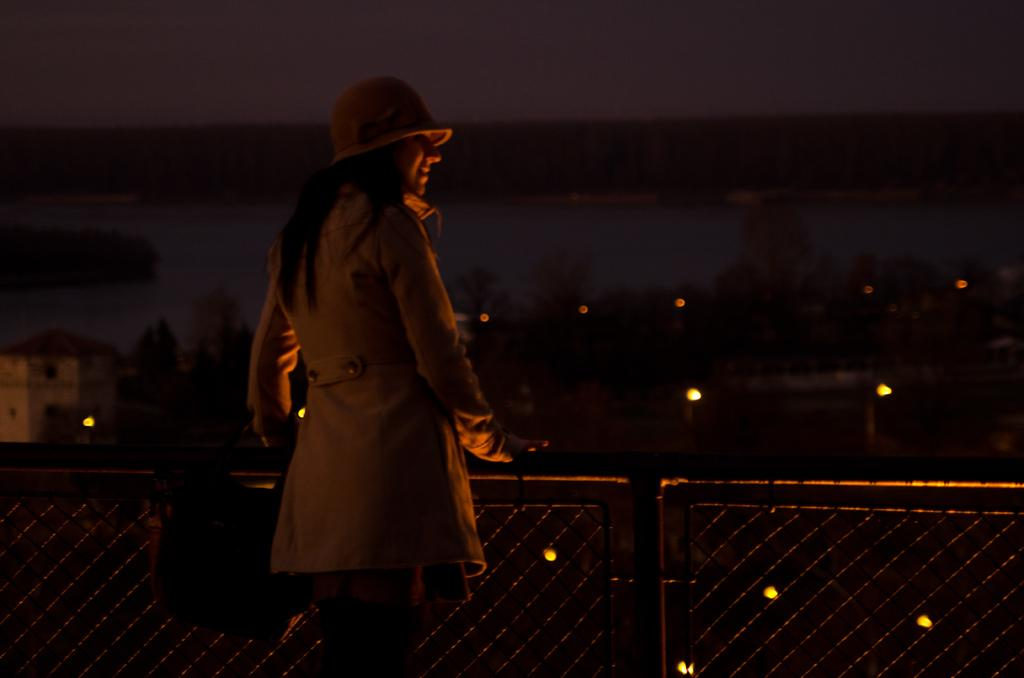Who is present in the image? There is a woman in the image. What is the woman wearing on her head? The woman is wearing a hat. What is the woman's posture in the image? The woman is standing. What type of structures can be seen in the image? There are buildings in the image. What type of vegetation is present in the image? There are trees in the image. What type of illumination is present in the image? There are lights in the image. What type of natural element is visible in the image? There is water visible in the image. What type of barrier is present in the image? There is a fence in the image. What can be seen in the background of the image? The sky is visible in the background of the image. What type of fowl can be seen flying over the fence in the image? There is no fowl visible in the image; it only features a woman, buildings, trees, lights, water, and a fence. 